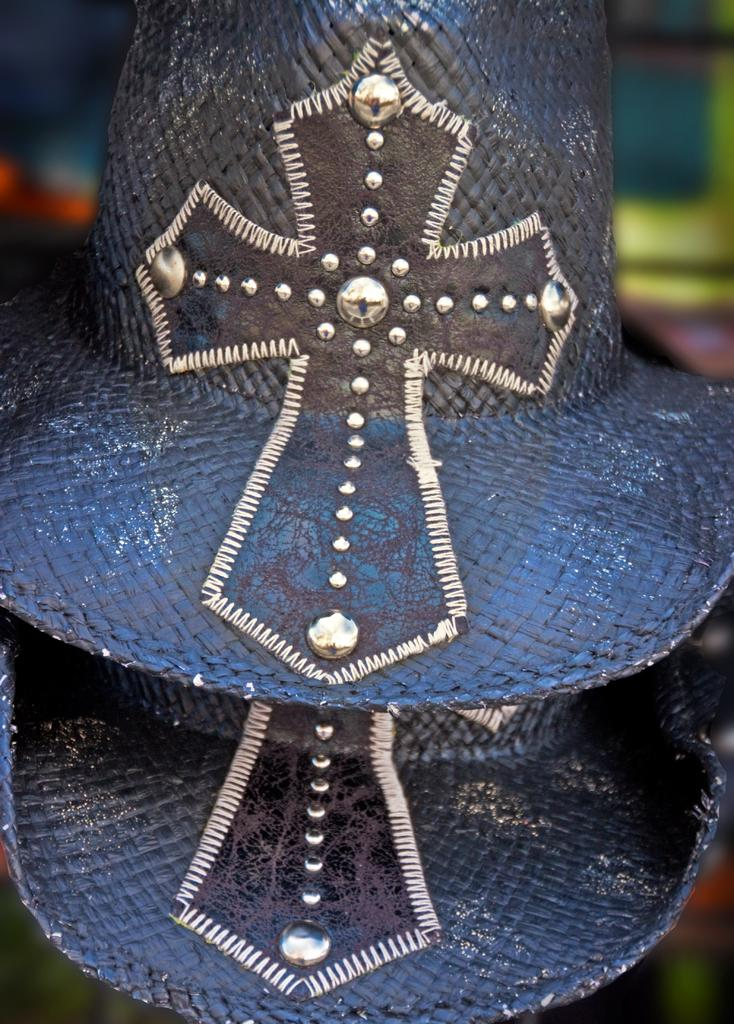How many hats can be seen in the image? There are two hats in the image. Can you describe the background of the image? The background of the image is blurry. Where is the faucet located in the image? There is no faucet present in the image. What type of writing instrument is used by the person wearing the veil in the image? There is no person wearing a veil or using a writing instrument in the image. 